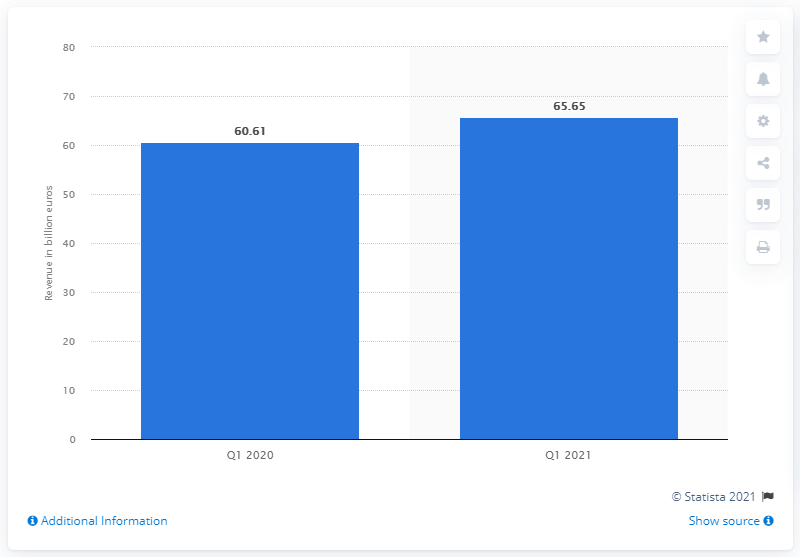Mention a couple of crucial points in this snapshot. In the first quarter of 2019, the three companies generated a collective revenue of 65.65... 